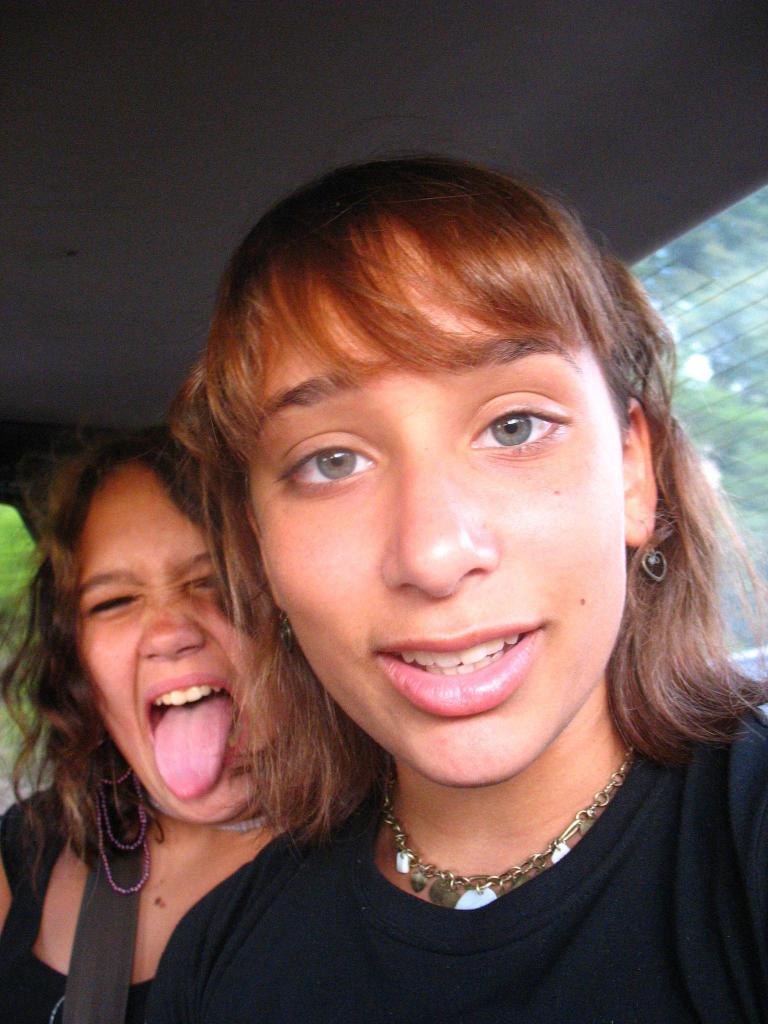How many people are inside the vehicle in the image? There are two persons in the vehicle. What material is used for the windows of the vehicle? There is glass in the vehicle. What can be seen through the glass of the vehicle? Trees are visible through the glass of the vehicle. What part of the vehicle is visible in the image? The roof of the vehicle is visible. How many dolls are sitting on the roof of the vehicle in the image? There are no dolls present in the image, and the roof of the vehicle is visible but not occupied by any dolls. 